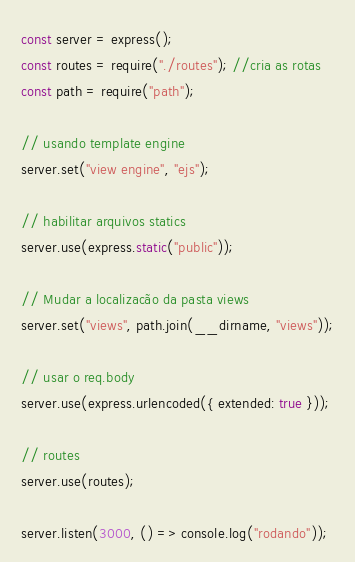<code> <loc_0><loc_0><loc_500><loc_500><_JavaScript_>const server = express();
const routes = require("./routes"); //cria as rotas
const path = require("path");

// usando template engine
server.set("view engine", "ejs");

// habilitar arquivos statics
server.use(express.static("public"));

// Mudar a localizacão da pasta views
server.set("views", path.join(__dirname, "views"));

// usar o req.body
server.use(express.urlencoded({ extended: true }));

// routes
server.use(routes);

server.listen(3000, () => console.log("rodando"));
</code> 